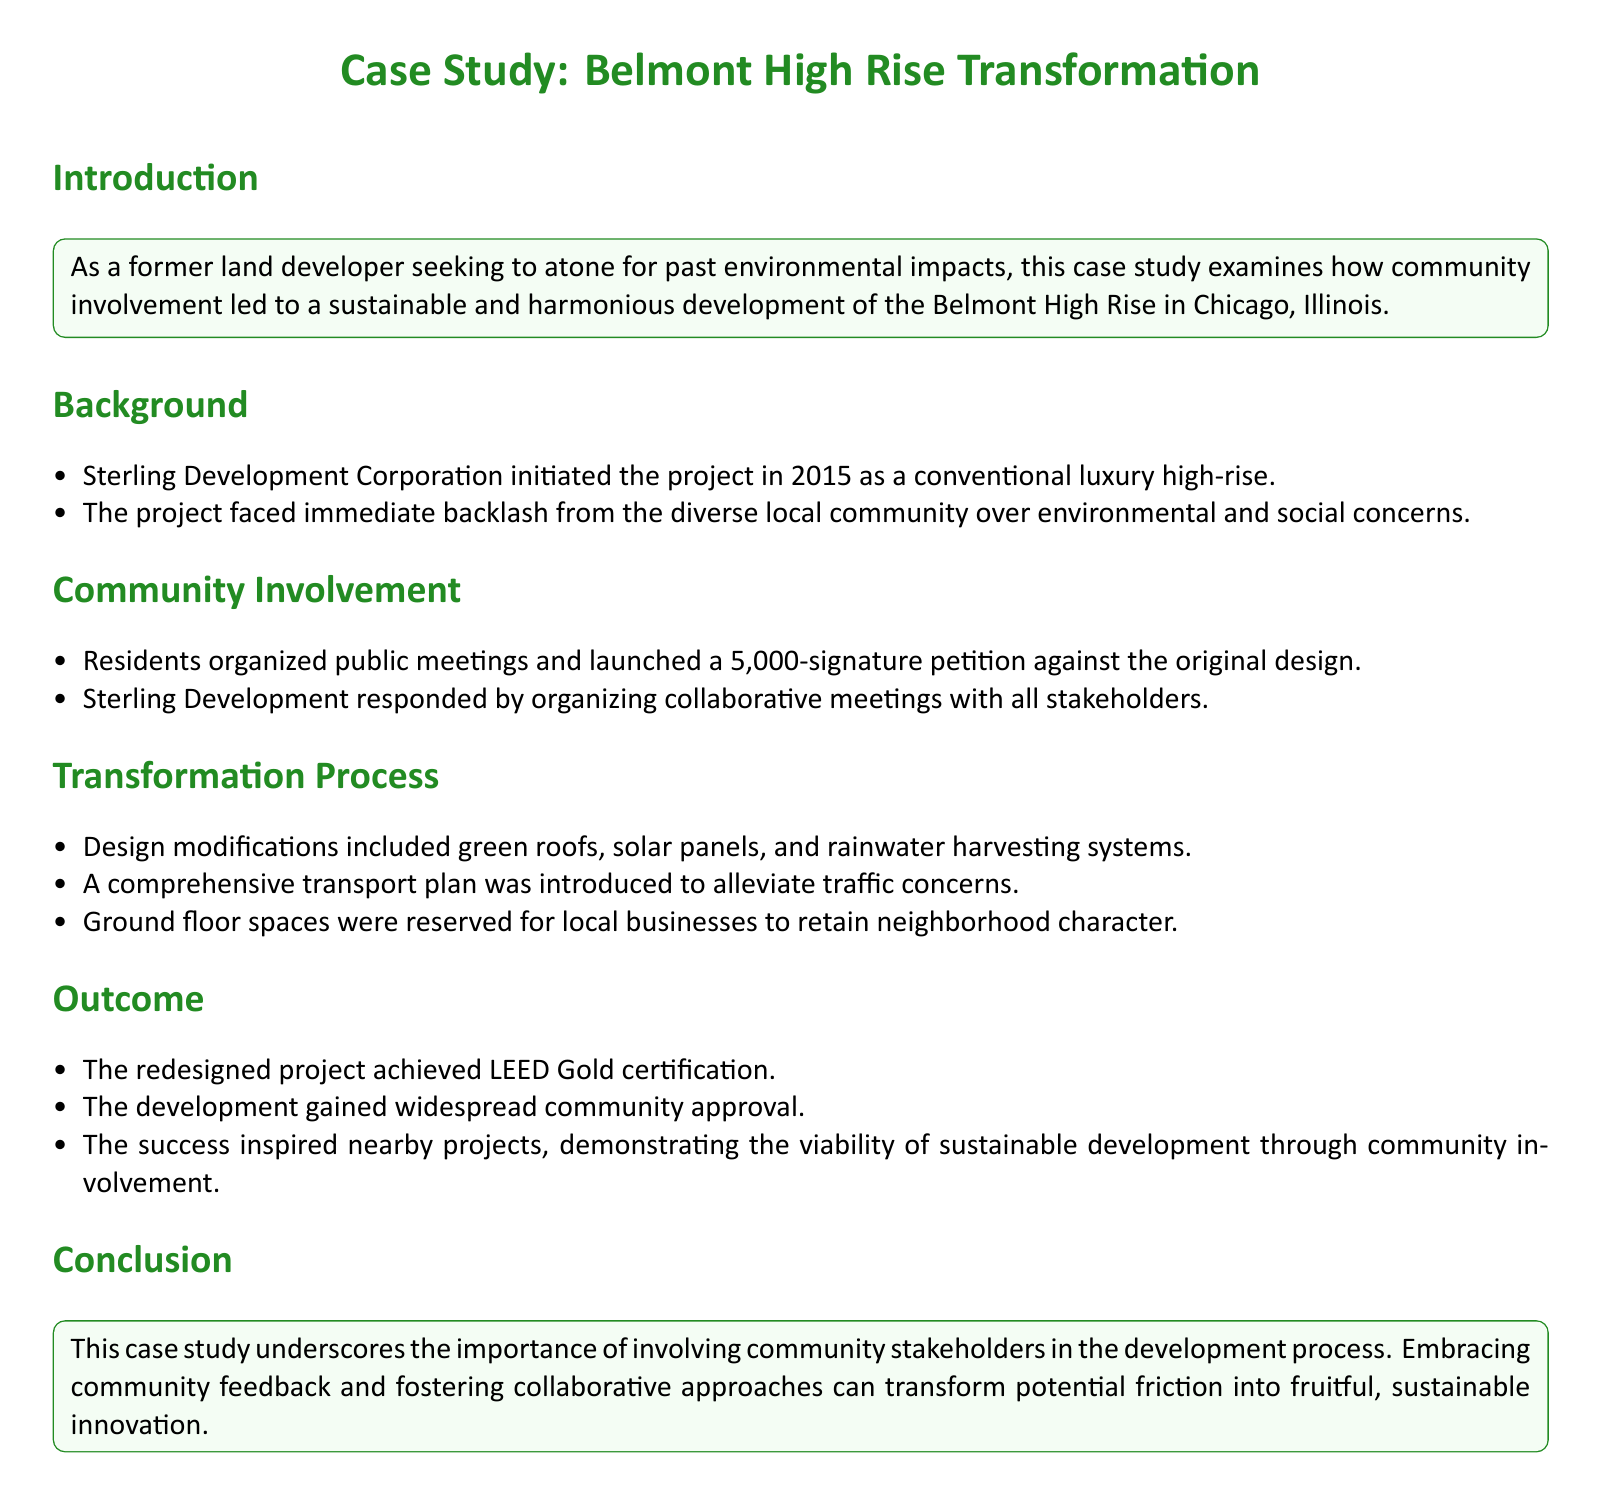What year did Sterling Development Corporation initiate the project? The document states that Sterling Development Corporation initiated the project in 2015.
Answer: 2015 What certification did the redesigned project achieve? According to the outcome section, the redesigned project achieved LEED Gold certification.
Answer: LEED Gold How many signatures were on the petition against the original design? The document mentions that residents launched a 5,000-signature petition against the original design.
Answer: 5,000 What feature was included to address traffic concerns? A comprehensive transport plan was introduced to alleviate traffic concerns, as noted in the transformation process section.
Answer: Transport plan What unique aspect was incorporated for local businesses? The ground floor spaces were reserved for local businesses, which is highlighted in the transformation process.
Answer: Reserved for local businesses What was the primary intention behind community involvement in the project? The introduction states that community involvement was aimed at transforming the high-rise project into a sustainable living space.
Answer: Sustainable living space In what city did the Belmont High Rise project take place? The document specifies that the Belmont High Rise is located in Chicago, Illinois.
Answer: Chicago, Illinois What action did Sterling Development take in response to community backlash? The document states that Sterling Development organized collaborative meetings with all stakeholders in response to community feedback.
Answer: Collaborative meetings 